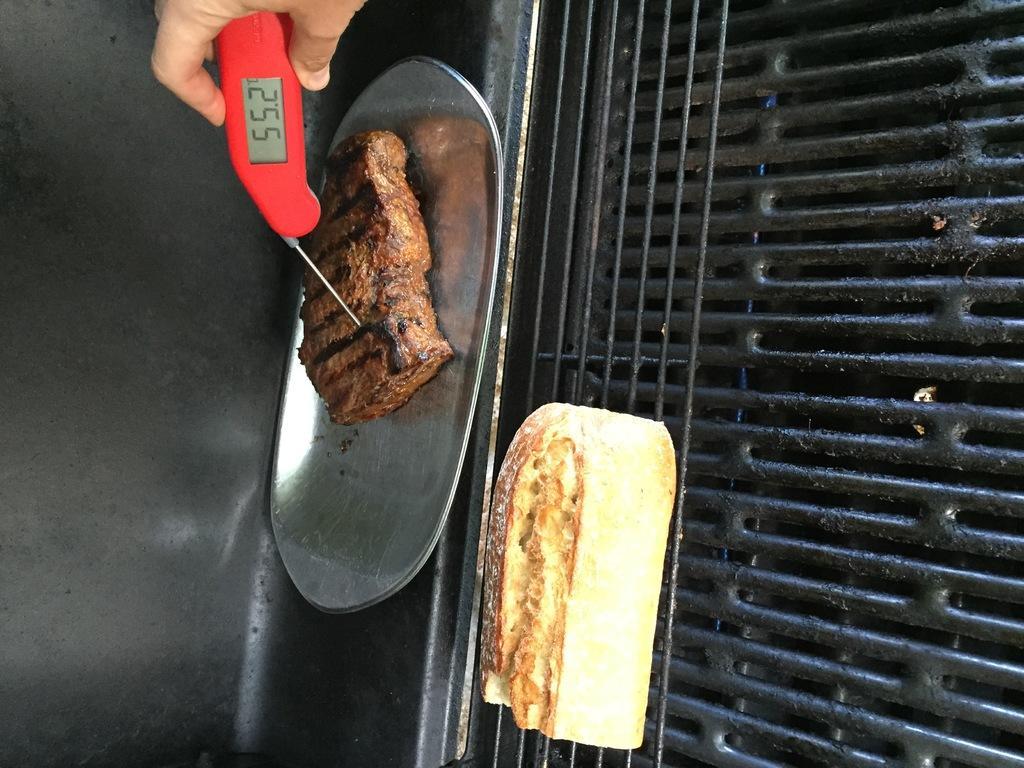Could you give a brief overview of what you see in this image? In this image we can see a plate with food item and a food item on the grill and a person's hand holding an object. 